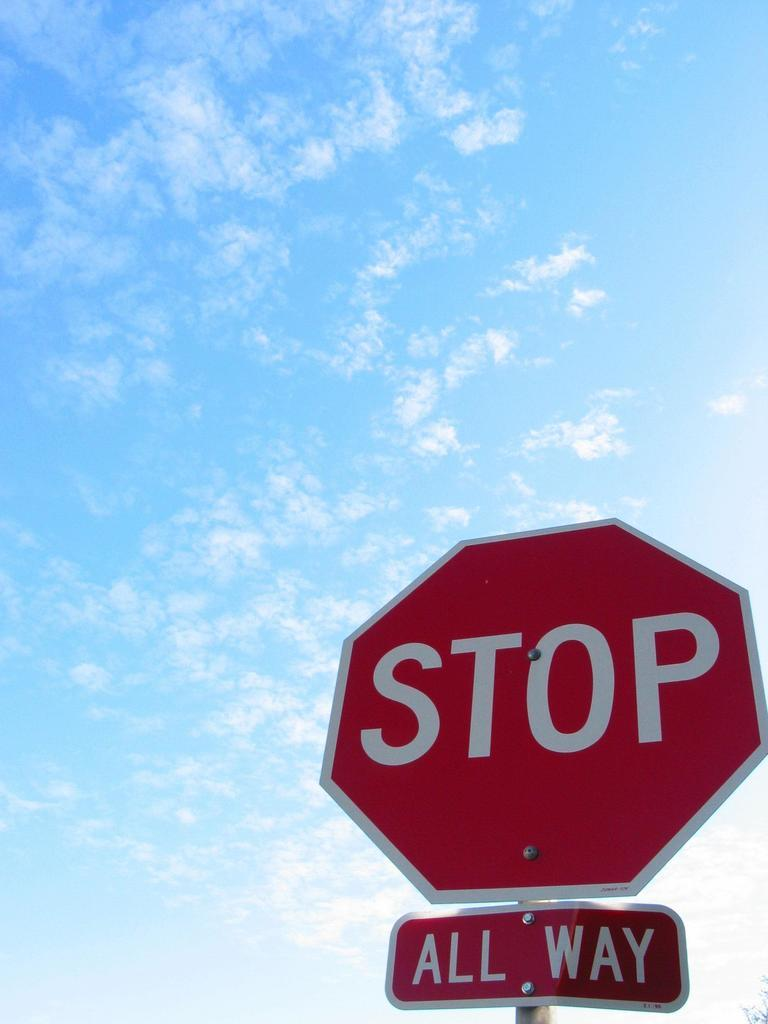Provide a one-sentence caption for the provided image. The sign below the stop sign indicates that this is an all way stop. 